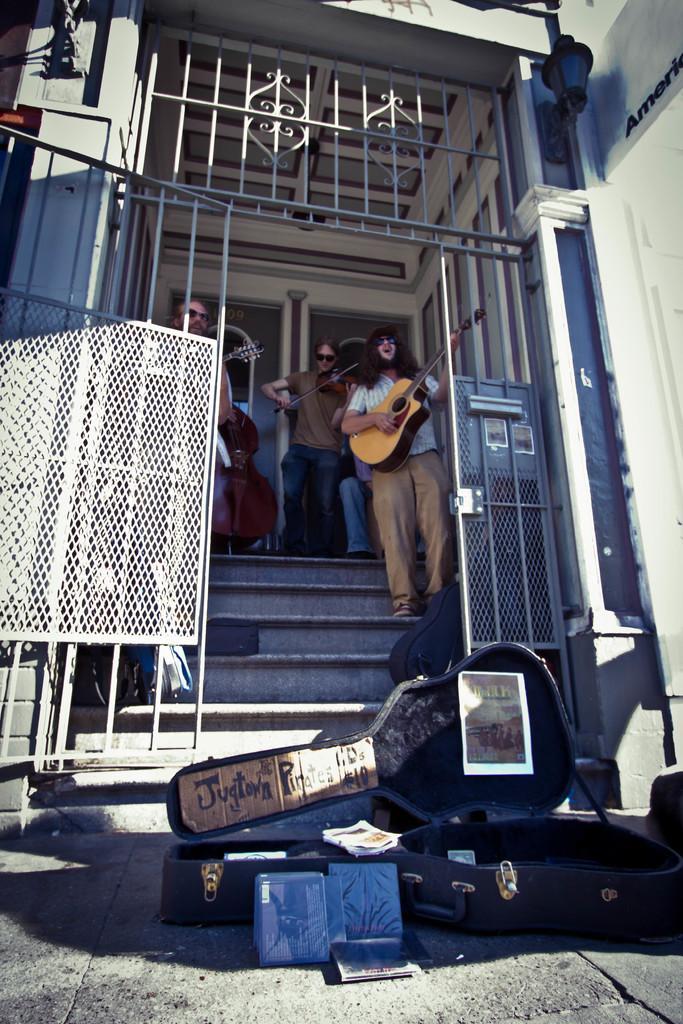Can you describe this image briefly? there is a black guitar box which is open and kept on the floor in front of a building. behind that there are stairs of a building on which 3 people are standing. the person at the right is playing guitar and wearing goggles. the person at the center is playing violin. left to him there is another violin. beside that, at the left a person is standing holding a guitar. behind that there is a door. in the front there is a steel door. 